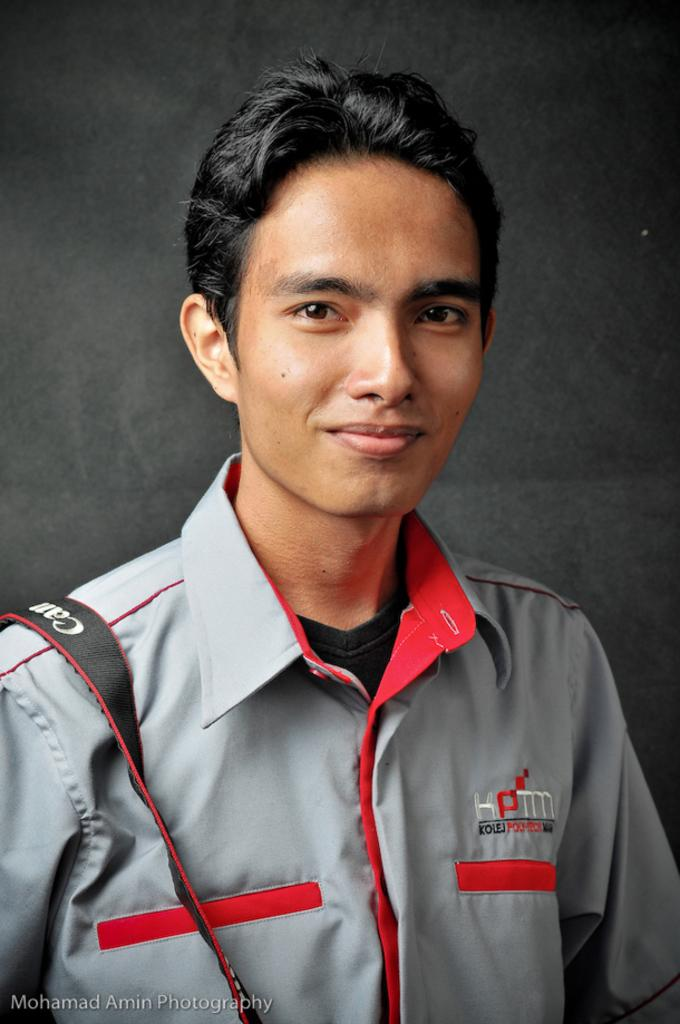<image>
Relay a brief, clear account of the picture shown. A man is wearing a grey and orange collared shirt with a Cannon Camera strap over his right shoulder. 